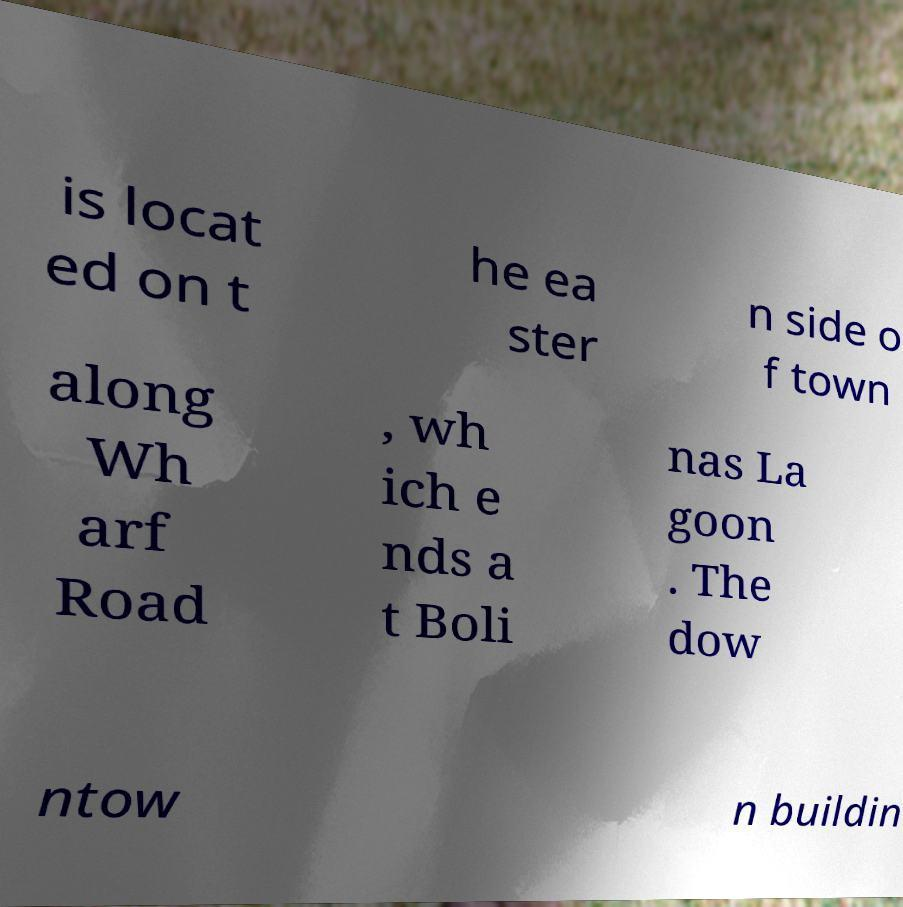For documentation purposes, I need the text within this image transcribed. Could you provide that? is locat ed on t he ea ster n side o f town along Wh arf Road , wh ich e nds a t Boli nas La goon . The dow ntow n buildin 